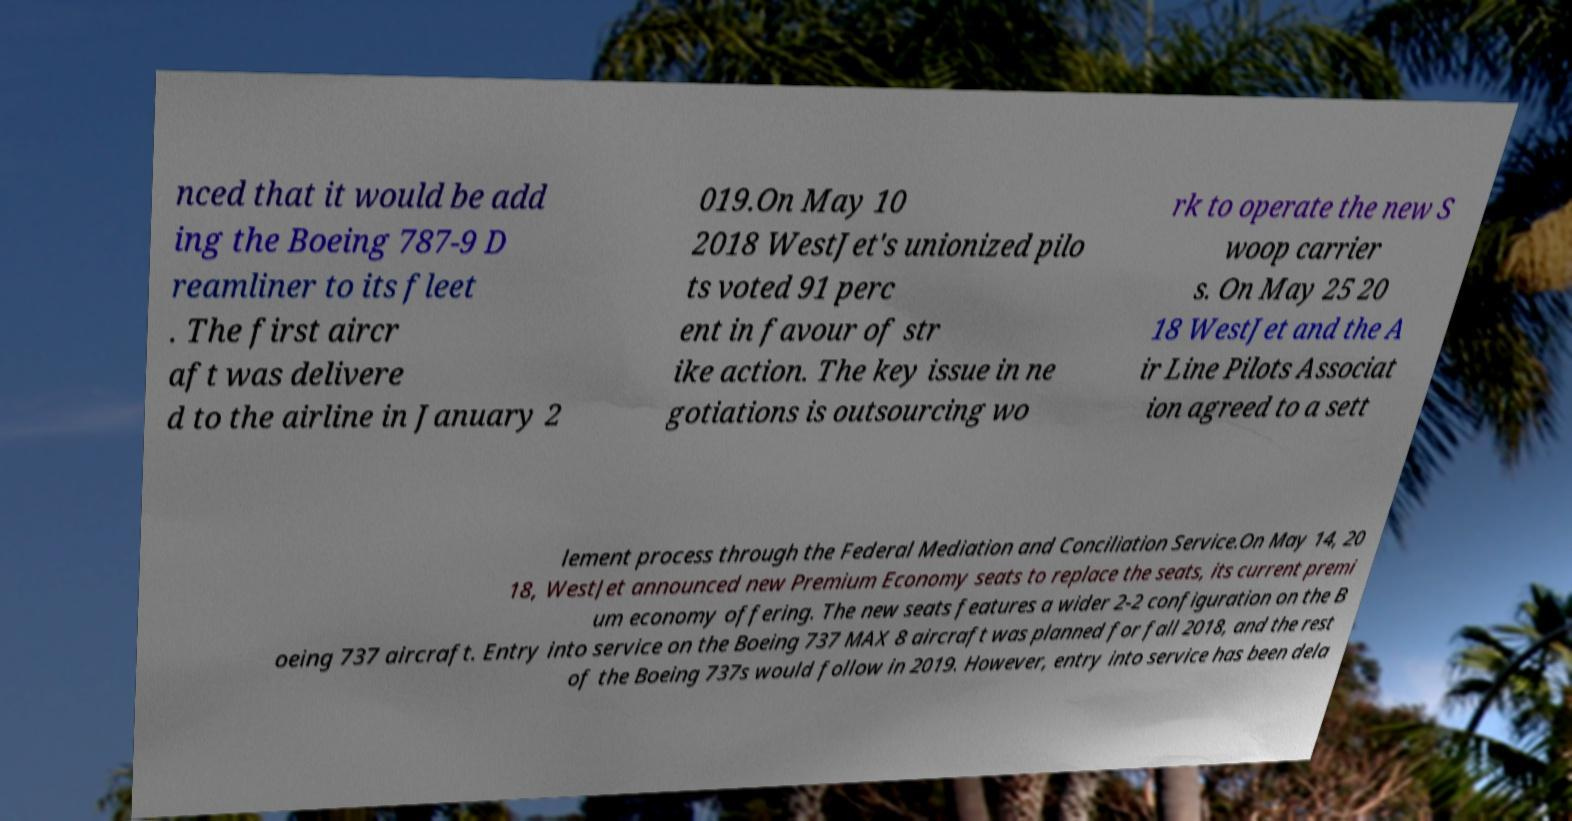Could you extract and type out the text from this image? nced that it would be add ing the Boeing 787-9 D reamliner to its fleet . The first aircr aft was delivere d to the airline in January 2 019.On May 10 2018 WestJet's unionized pilo ts voted 91 perc ent in favour of str ike action. The key issue in ne gotiations is outsourcing wo rk to operate the new S woop carrier s. On May 25 20 18 WestJet and the A ir Line Pilots Associat ion agreed to a sett lement process through the Federal Mediation and Conciliation Service.On May 14, 20 18, WestJet announced new Premium Economy seats to replace the seats, its current premi um economy offering. The new seats features a wider 2-2 configuration on the B oeing 737 aircraft. Entry into service on the Boeing 737 MAX 8 aircraft was planned for fall 2018, and the rest of the Boeing 737s would follow in 2019. However, entry into service has been dela 